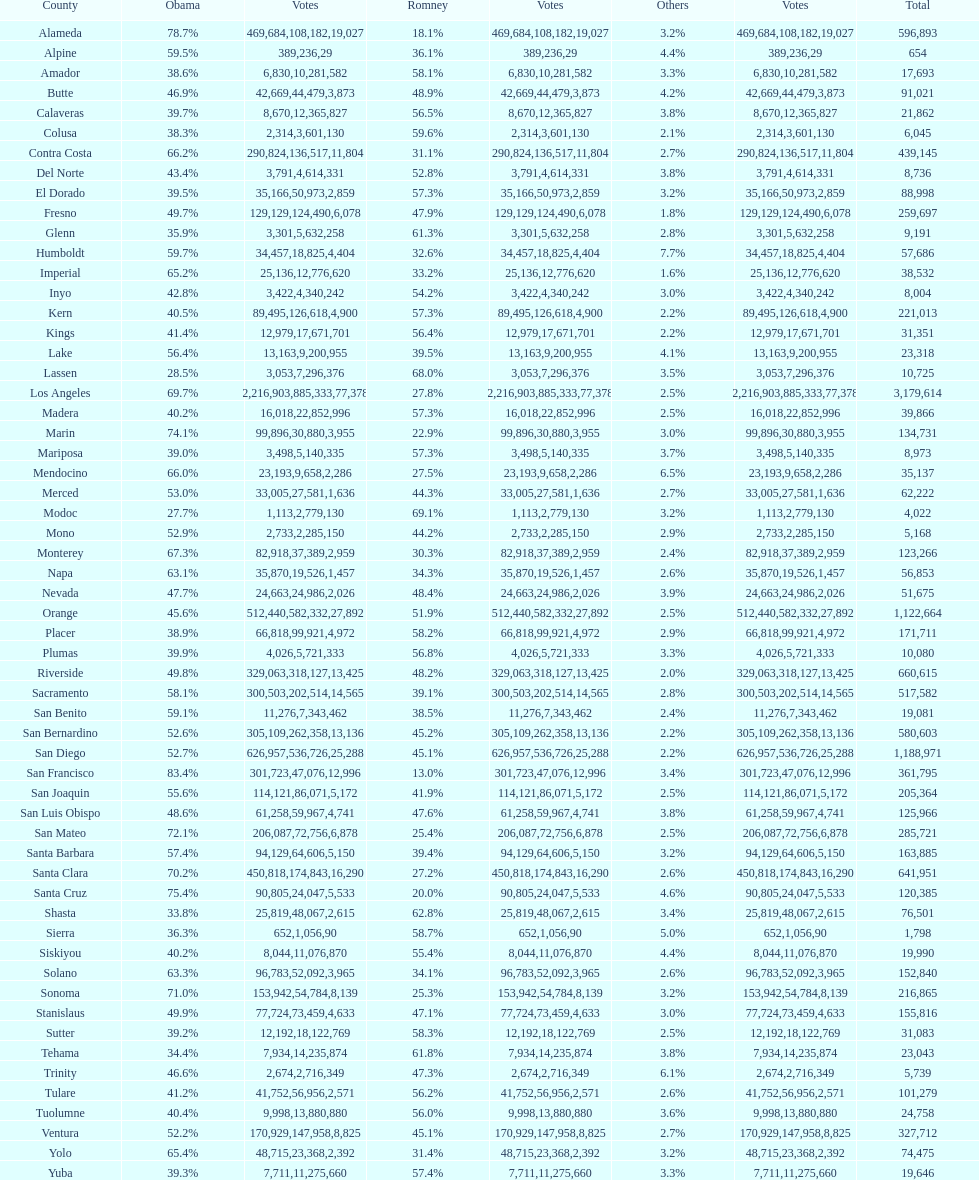Which county comes immediately before del norte on the list? Contra Costa. 